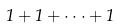Convert formula to latex. <formula><loc_0><loc_0><loc_500><loc_500>1 + 1 + \cdot \cdot \cdot + 1</formula> 